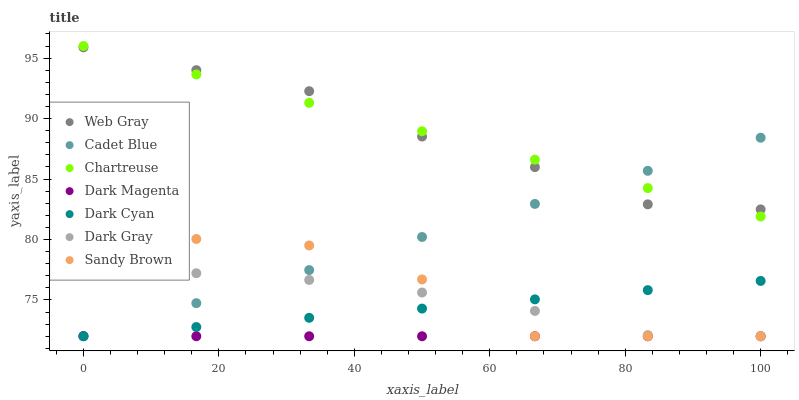Does Dark Magenta have the minimum area under the curve?
Answer yes or no. Yes. Does Chartreuse have the maximum area under the curve?
Answer yes or no. Yes. Does Dark Gray have the minimum area under the curve?
Answer yes or no. No. Does Dark Gray have the maximum area under the curve?
Answer yes or no. No. Is Cadet Blue the smoothest?
Answer yes or no. Yes. Is Sandy Brown the roughest?
Answer yes or no. Yes. Is Dark Magenta the smoothest?
Answer yes or no. No. Is Dark Magenta the roughest?
Answer yes or no. No. Does Cadet Blue have the lowest value?
Answer yes or no. Yes. Does Chartreuse have the lowest value?
Answer yes or no. No. Does Chartreuse have the highest value?
Answer yes or no. Yes. Does Dark Gray have the highest value?
Answer yes or no. No. Is Dark Cyan less than Chartreuse?
Answer yes or no. Yes. Is Web Gray greater than Sandy Brown?
Answer yes or no. Yes. Does Dark Magenta intersect Cadet Blue?
Answer yes or no. Yes. Is Dark Magenta less than Cadet Blue?
Answer yes or no. No. Is Dark Magenta greater than Cadet Blue?
Answer yes or no. No. Does Dark Cyan intersect Chartreuse?
Answer yes or no. No. 